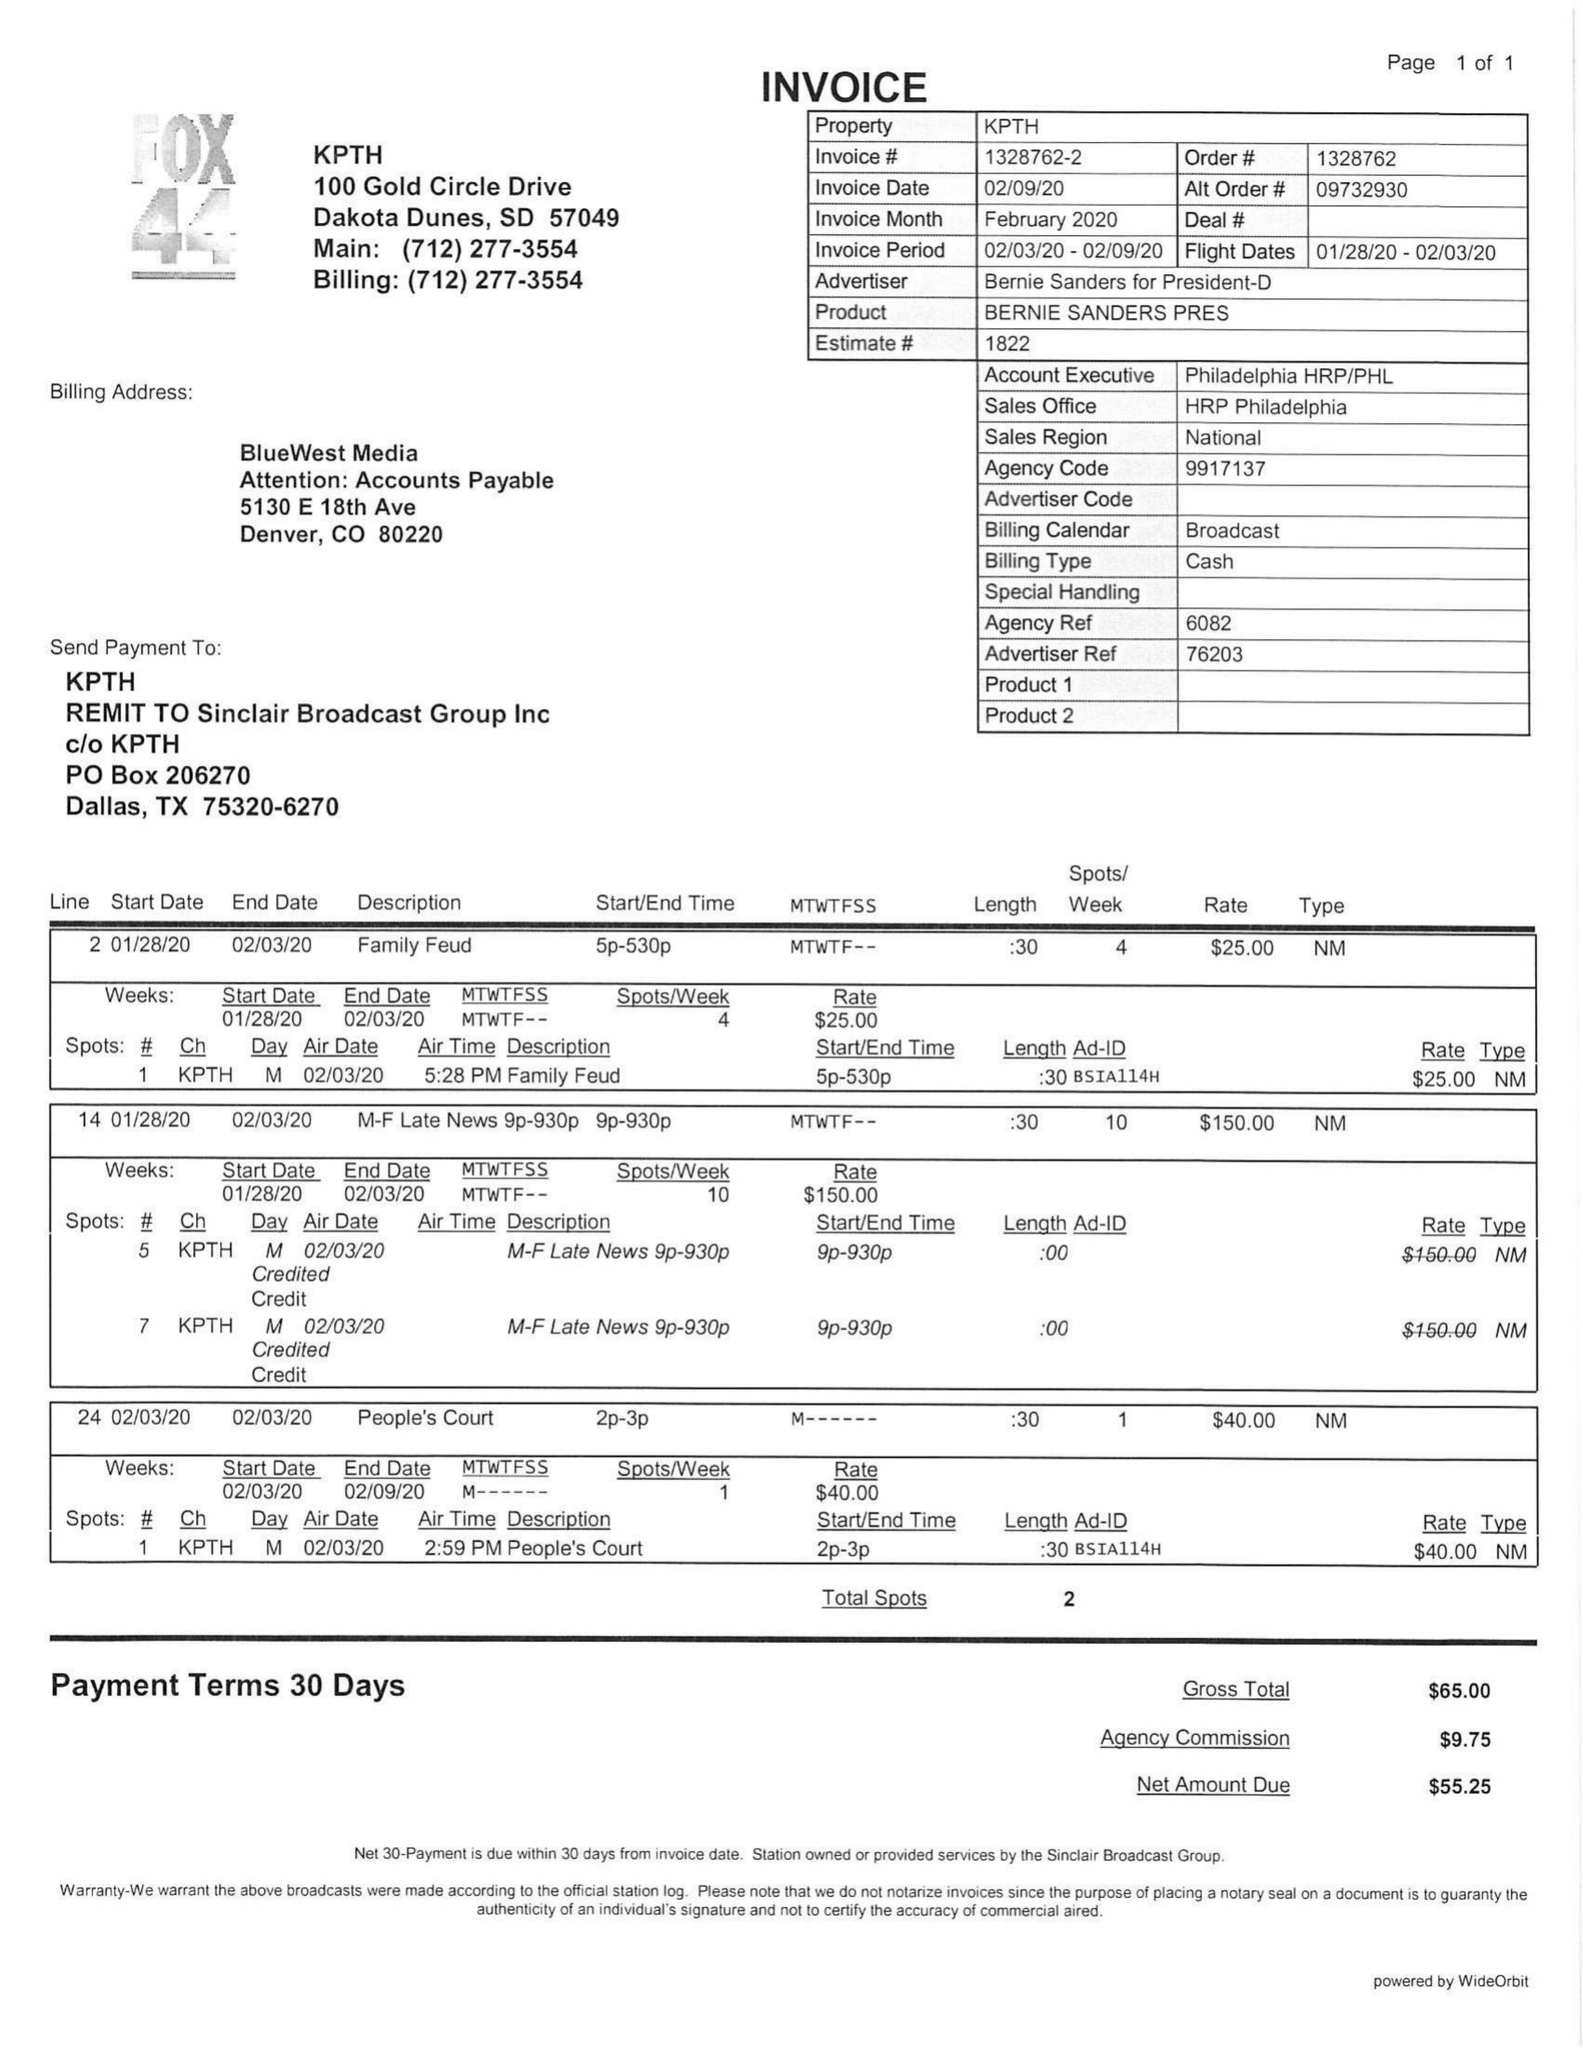What is the value for the contract_num?
Answer the question using a single word or phrase. 1328762 